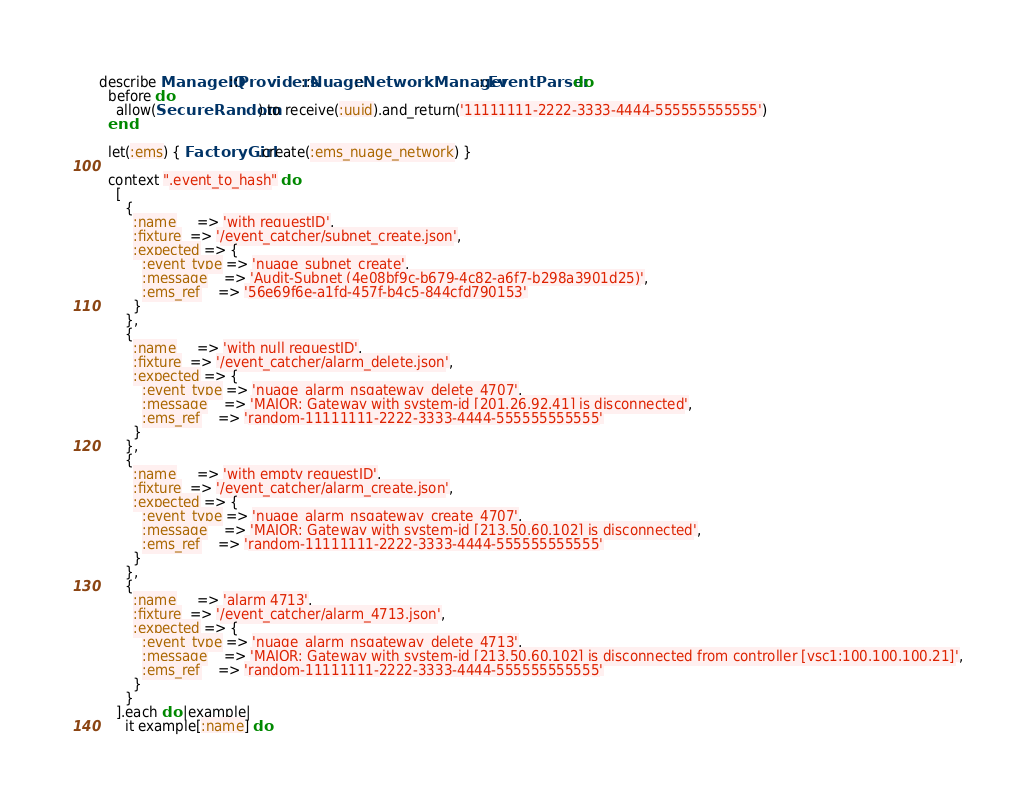<code> <loc_0><loc_0><loc_500><loc_500><_Ruby_>describe ManageIQ::Providers::Nuage::NetworkManager::EventParser do
  before do
    allow(SecureRandom).to receive(:uuid).and_return('11111111-2222-3333-4444-555555555555')
  end

  let(:ems) { FactoryGirl.create(:ems_nuage_network) }

  context ".event_to_hash" do
    [
      {
        :name     => 'with requestID',
        :fixture  => '/event_catcher/subnet_create.json',
        :expected => {
          :event_type => 'nuage_subnet_create',
          :message    => 'Audit-Subnet (4e08bf9c-b679-4c82-a6f7-b298a3901d25)',
          :ems_ref    => '56e69f6e-a1fd-457f-b4c5-844cfd790153'
        }
      },
      {
        :name     => 'with null requestID',
        :fixture  => '/event_catcher/alarm_delete.json',
        :expected => {
          :event_type => 'nuage_alarm_nsgateway_delete_4707',
          :message    => 'MAJOR: Gateway with system-id [201.26.92.41] is disconnected',
          :ems_ref    => 'random-11111111-2222-3333-4444-555555555555'
        }
      },
      {
        :name     => 'with empty requestID',
        :fixture  => '/event_catcher/alarm_create.json',
        :expected => {
          :event_type => 'nuage_alarm_nsgateway_create_4707',
          :message    => 'MAJOR: Gateway with system-id [213.50.60.102] is disconnected',
          :ems_ref    => 'random-11111111-2222-3333-4444-555555555555'
        }
      },
      {
        :name     => 'alarm 4713',
        :fixture  => '/event_catcher/alarm_4713.json',
        :expected => {
          :event_type => 'nuage_alarm_nsgateway_delete_4713',
          :message    => 'MAJOR: Gateway with system-id [213.50.60.102] is disconnected from controller [vsc1:100.100.100.21]',
          :ems_ref    => 'random-11111111-2222-3333-4444-555555555555'
        }
      }
    ].each do |example|
      it example[:name] do</code> 